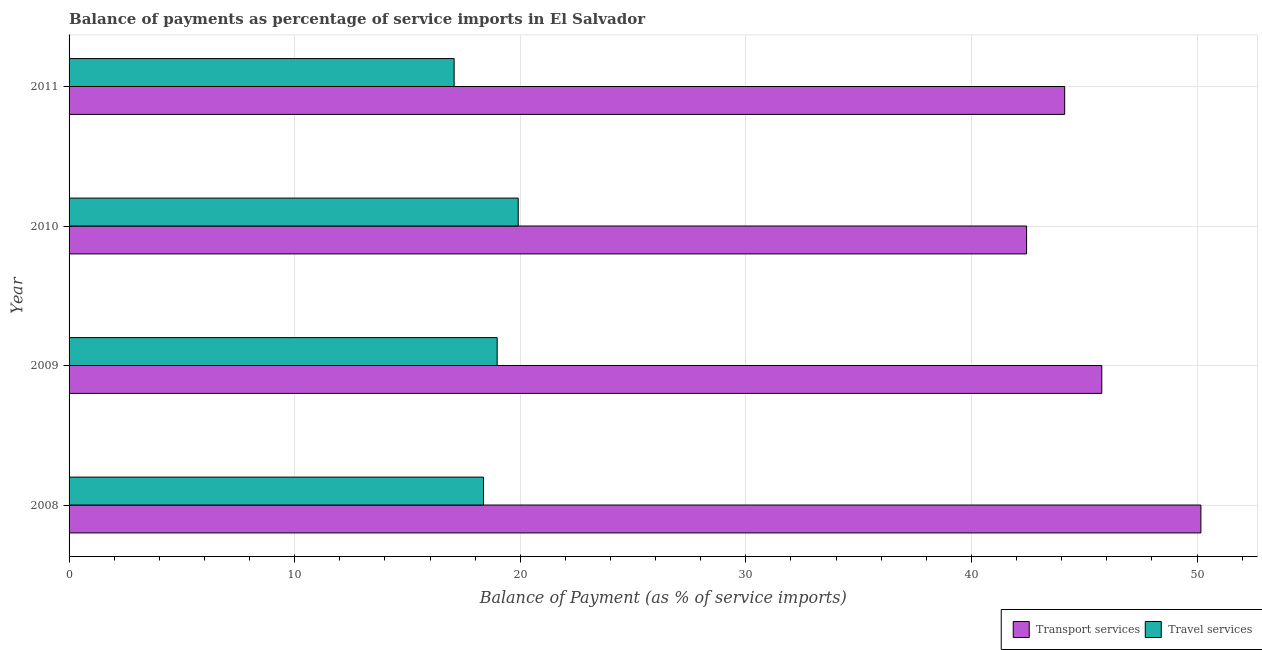How many groups of bars are there?
Offer a terse response. 4. Are the number of bars on each tick of the Y-axis equal?
Make the answer very short. Yes. How many bars are there on the 4th tick from the top?
Offer a terse response. 2. What is the balance of payments of travel services in 2008?
Give a very brief answer. 18.37. Across all years, what is the maximum balance of payments of travel services?
Your answer should be very brief. 19.91. Across all years, what is the minimum balance of payments of travel services?
Keep it short and to the point. 17.07. What is the total balance of payments of transport services in the graph?
Your response must be concise. 182.53. What is the difference between the balance of payments of travel services in 2010 and that in 2011?
Offer a very short reply. 2.84. What is the difference between the balance of payments of travel services in 2008 and the balance of payments of transport services in 2010?
Provide a succinct answer. -24.08. What is the average balance of payments of travel services per year?
Offer a terse response. 18.58. In the year 2011, what is the difference between the balance of payments of travel services and balance of payments of transport services?
Ensure brevity in your answer.  -27.06. In how many years, is the balance of payments of transport services greater than 16 %?
Offer a terse response. 4. Is the balance of payments of transport services in 2008 less than that in 2009?
Provide a succinct answer. No. Is the difference between the balance of payments of transport services in 2008 and 2009 greater than the difference between the balance of payments of travel services in 2008 and 2009?
Give a very brief answer. Yes. What is the difference between the highest and the second highest balance of payments of transport services?
Make the answer very short. 4.39. What is the difference between the highest and the lowest balance of payments of travel services?
Offer a terse response. 2.84. In how many years, is the balance of payments of travel services greater than the average balance of payments of travel services taken over all years?
Provide a short and direct response. 2. What does the 2nd bar from the top in 2010 represents?
Provide a succinct answer. Transport services. What does the 1st bar from the bottom in 2011 represents?
Offer a terse response. Transport services. How many bars are there?
Ensure brevity in your answer.  8. Are all the bars in the graph horizontal?
Provide a succinct answer. Yes. What is the difference between two consecutive major ticks on the X-axis?
Keep it short and to the point. 10. Are the values on the major ticks of X-axis written in scientific E-notation?
Give a very brief answer. No. How many legend labels are there?
Your answer should be very brief. 2. What is the title of the graph?
Give a very brief answer. Balance of payments as percentage of service imports in El Salvador. What is the label or title of the X-axis?
Your answer should be compact. Balance of Payment (as % of service imports). What is the Balance of Payment (as % of service imports) in Transport services in 2008?
Make the answer very short. 50.17. What is the Balance of Payment (as % of service imports) in Travel services in 2008?
Provide a succinct answer. 18.37. What is the Balance of Payment (as % of service imports) in Transport services in 2009?
Your answer should be very brief. 45.78. What is the Balance of Payment (as % of service imports) of Travel services in 2009?
Offer a terse response. 18.98. What is the Balance of Payment (as % of service imports) in Transport services in 2010?
Your answer should be very brief. 42.44. What is the Balance of Payment (as % of service imports) in Travel services in 2010?
Make the answer very short. 19.91. What is the Balance of Payment (as % of service imports) in Transport services in 2011?
Keep it short and to the point. 44.13. What is the Balance of Payment (as % of service imports) in Travel services in 2011?
Give a very brief answer. 17.07. Across all years, what is the maximum Balance of Payment (as % of service imports) in Transport services?
Ensure brevity in your answer.  50.17. Across all years, what is the maximum Balance of Payment (as % of service imports) in Travel services?
Give a very brief answer. 19.91. Across all years, what is the minimum Balance of Payment (as % of service imports) in Transport services?
Your response must be concise. 42.44. Across all years, what is the minimum Balance of Payment (as % of service imports) of Travel services?
Give a very brief answer. 17.07. What is the total Balance of Payment (as % of service imports) in Transport services in the graph?
Offer a very short reply. 182.53. What is the total Balance of Payment (as % of service imports) of Travel services in the graph?
Offer a very short reply. 74.32. What is the difference between the Balance of Payment (as % of service imports) in Transport services in 2008 and that in 2009?
Provide a short and direct response. 4.39. What is the difference between the Balance of Payment (as % of service imports) in Travel services in 2008 and that in 2009?
Keep it short and to the point. -0.61. What is the difference between the Balance of Payment (as % of service imports) in Transport services in 2008 and that in 2010?
Give a very brief answer. 7.73. What is the difference between the Balance of Payment (as % of service imports) of Travel services in 2008 and that in 2010?
Your response must be concise. -1.54. What is the difference between the Balance of Payment (as % of service imports) in Transport services in 2008 and that in 2011?
Your answer should be very brief. 6.04. What is the difference between the Balance of Payment (as % of service imports) in Travel services in 2008 and that in 2011?
Provide a succinct answer. 1.3. What is the difference between the Balance of Payment (as % of service imports) of Transport services in 2009 and that in 2010?
Give a very brief answer. 3.33. What is the difference between the Balance of Payment (as % of service imports) of Travel services in 2009 and that in 2010?
Offer a very short reply. -0.93. What is the difference between the Balance of Payment (as % of service imports) of Transport services in 2009 and that in 2011?
Your response must be concise. 1.65. What is the difference between the Balance of Payment (as % of service imports) of Travel services in 2009 and that in 2011?
Ensure brevity in your answer.  1.91. What is the difference between the Balance of Payment (as % of service imports) of Transport services in 2010 and that in 2011?
Offer a very short reply. -1.69. What is the difference between the Balance of Payment (as % of service imports) in Travel services in 2010 and that in 2011?
Keep it short and to the point. 2.84. What is the difference between the Balance of Payment (as % of service imports) in Transport services in 2008 and the Balance of Payment (as % of service imports) in Travel services in 2009?
Your response must be concise. 31.19. What is the difference between the Balance of Payment (as % of service imports) in Transport services in 2008 and the Balance of Payment (as % of service imports) in Travel services in 2010?
Make the answer very short. 30.26. What is the difference between the Balance of Payment (as % of service imports) of Transport services in 2008 and the Balance of Payment (as % of service imports) of Travel services in 2011?
Your response must be concise. 33.1. What is the difference between the Balance of Payment (as % of service imports) in Transport services in 2009 and the Balance of Payment (as % of service imports) in Travel services in 2010?
Make the answer very short. 25.87. What is the difference between the Balance of Payment (as % of service imports) of Transport services in 2009 and the Balance of Payment (as % of service imports) of Travel services in 2011?
Provide a succinct answer. 28.71. What is the difference between the Balance of Payment (as % of service imports) of Transport services in 2010 and the Balance of Payment (as % of service imports) of Travel services in 2011?
Provide a succinct answer. 25.38. What is the average Balance of Payment (as % of service imports) of Transport services per year?
Your answer should be compact. 45.63. What is the average Balance of Payment (as % of service imports) of Travel services per year?
Offer a terse response. 18.58. In the year 2008, what is the difference between the Balance of Payment (as % of service imports) of Transport services and Balance of Payment (as % of service imports) of Travel services?
Give a very brief answer. 31.8. In the year 2009, what is the difference between the Balance of Payment (as % of service imports) of Transport services and Balance of Payment (as % of service imports) of Travel services?
Your response must be concise. 26.8. In the year 2010, what is the difference between the Balance of Payment (as % of service imports) in Transport services and Balance of Payment (as % of service imports) in Travel services?
Provide a short and direct response. 22.54. In the year 2011, what is the difference between the Balance of Payment (as % of service imports) in Transport services and Balance of Payment (as % of service imports) in Travel services?
Your answer should be compact. 27.06. What is the ratio of the Balance of Payment (as % of service imports) of Transport services in 2008 to that in 2009?
Ensure brevity in your answer.  1.1. What is the ratio of the Balance of Payment (as % of service imports) of Travel services in 2008 to that in 2009?
Keep it short and to the point. 0.97. What is the ratio of the Balance of Payment (as % of service imports) in Transport services in 2008 to that in 2010?
Your answer should be very brief. 1.18. What is the ratio of the Balance of Payment (as % of service imports) of Travel services in 2008 to that in 2010?
Provide a short and direct response. 0.92. What is the ratio of the Balance of Payment (as % of service imports) in Transport services in 2008 to that in 2011?
Keep it short and to the point. 1.14. What is the ratio of the Balance of Payment (as % of service imports) of Travel services in 2008 to that in 2011?
Ensure brevity in your answer.  1.08. What is the ratio of the Balance of Payment (as % of service imports) of Transport services in 2009 to that in 2010?
Make the answer very short. 1.08. What is the ratio of the Balance of Payment (as % of service imports) in Travel services in 2009 to that in 2010?
Offer a very short reply. 0.95. What is the ratio of the Balance of Payment (as % of service imports) of Transport services in 2009 to that in 2011?
Provide a short and direct response. 1.04. What is the ratio of the Balance of Payment (as % of service imports) in Travel services in 2009 to that in 2011?
Ensure brevity in your answer.  1.11. What is the ratio of the Balance of Payment (as % of service imports) of Transport services in 2010 to that in 2011?
Offer a very short reply. 0.96. What is the ratio of the Balance of Payment (as % of service imports) in Travel services in 2010 to that in 2011?
Ensure brevity in your answer.  1.17. What is the difference between the highest and the second highest Balance of Payment (as % of service imports) in Transport services?
Your answer should be very brief. 4.39. What is the difference between the highest and the second highest Balance of Payment (as % of service imports) of Travel services?
Offer a terse response. 0.93. What is the difference between the highest and the lowest Balance of Payment (as % of service imports) of Transport services?
Ensure brevity in your answer.  7.73. What is the difference between the highest and the lowest Balance of Payment (as % of service imports) of Travel services?
Make the answer very short. 2.84. 